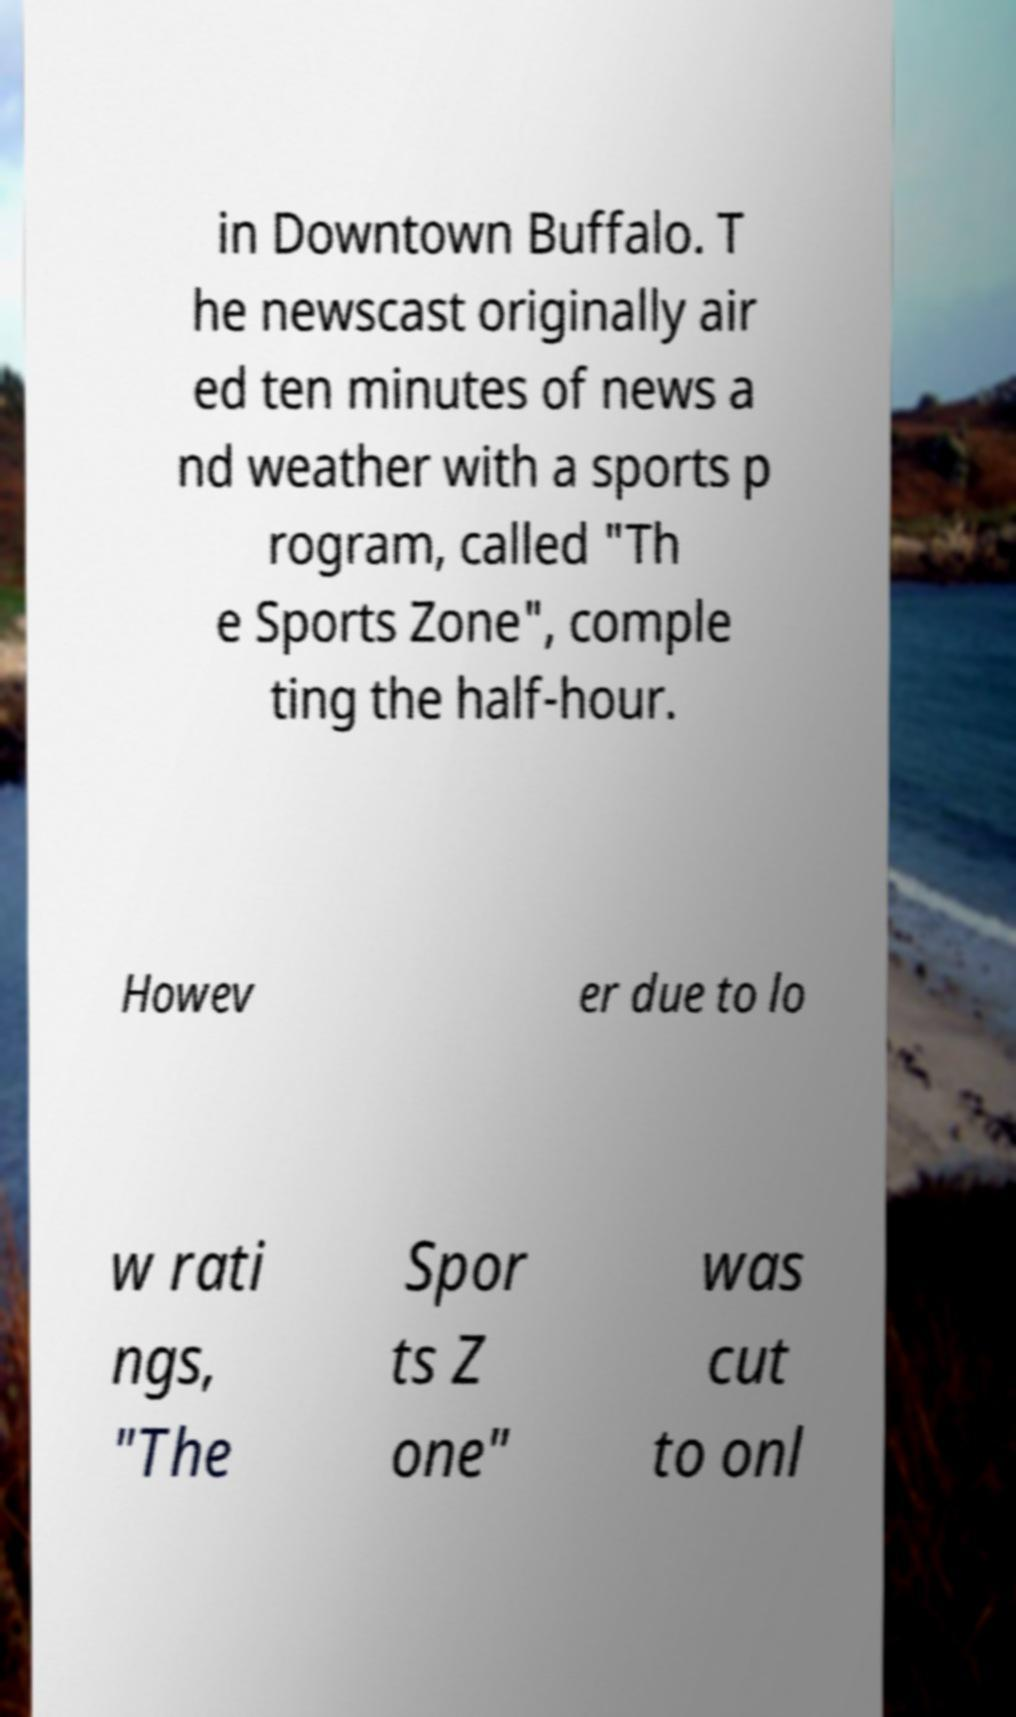There's text embedded in this image that I need extracted. Can you transcribe it verbatim? in Downtown Buffalo. T he newscast originally air ed ten minutes of news a nd weather with a sports p rogram, called "Th e Sports Zone", comple ting the half-hour. Howev er due to lo w rati ngs, "The Spor ts Z one" was cut to onl 